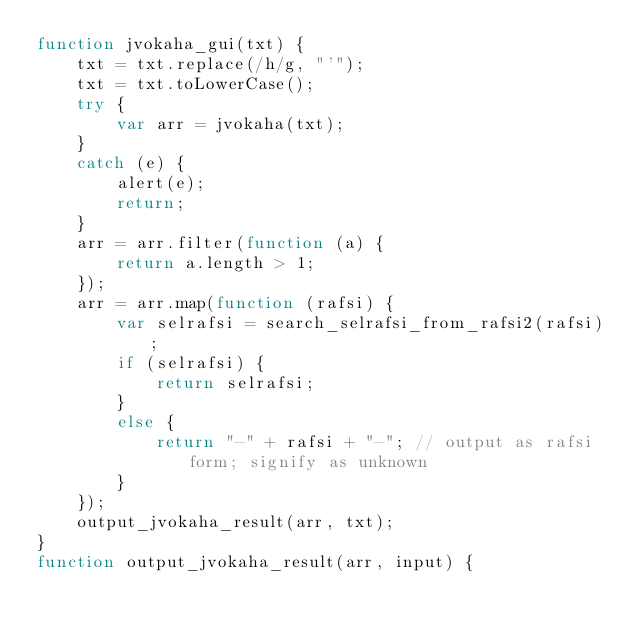<code> <loc_0><loc_0><loc_500><loc_500><_JavaScript_>function jvokaha_gui(txt) {
    txt = txt.replace(/h/g, "'");
    txt = txt.toLowerCase();
    try {
        var arr = jvokaha(txt);
    }
    catch (e) {
        alert(e);
        return;
    }
    arr = arr.filter(function (a) {
        return a.length > 1;
    });
    arr = arr.map(function (rafsi) {
        var selrafsi = search_selrafsi_from_rafsi2(rafsi);
        if (selrafsi) {
            return selrafsi;
        }
        else {
            return "-" + rafsi + "-"; // output as rafsi form; signify as unknown
        }
    });
    output_jvokaha_result(arr, txt);
}
function output_jvokaha_result(arr, input) {</code> 